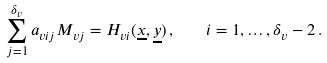Convert formula to latex. <formula><loc_0><loc_0><loc_500><loc_500>\sum _ { j = 1 } ^ { \delta _ { v } } a _ { v i j } M _ { v j } = H _ { v i } ( \underline { x } , \underline { y } ) \, , \quad i = 1 , \dots , \delta _ { v } - 2 \, .</formula> 